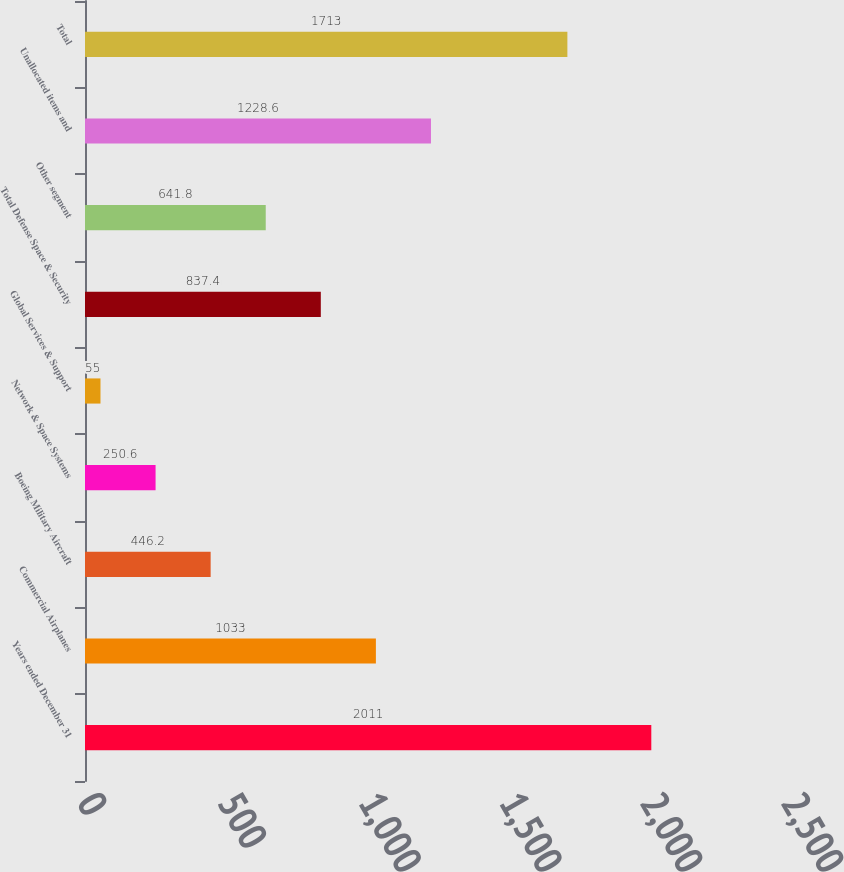Convert chart. <chart><loc_0><loc_0><loc_500><loc_500><bar_chart><fcel>Years ended December 31<fcel>Commercial Airplanes<fcel>Boeing Military Aircraft<fcel>Network & Space Systems<fcel>Global Services & Support<fcel>Total Defense Space & Security<fcel>Other segment<fcel>Unallocated items and<fcel>Total<nl><fcel>2011<fcel>1033<fcel>446.2<fcel>250.6<fcel>55<fcel>837.4<fcel>641.8<fcel>1228.6<fcel>1713<nl></chart> 